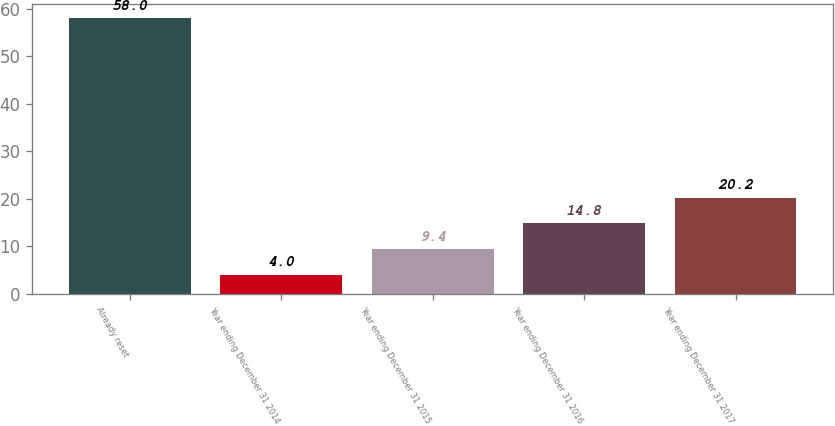<chart> <loc_0><loc_0><loc_500><loc_500><bar_chart><fcel>Already reset<fcel>Year ending December 31 2014<fcel>Year ending December 31 2015<fcel>Year ending December 31 2016<fcel>Year ending December 31 2017<nl><fcel>58<fcel>4<fcel>9.4<fcel>14.8<fcel>20.2<nl></chart> 